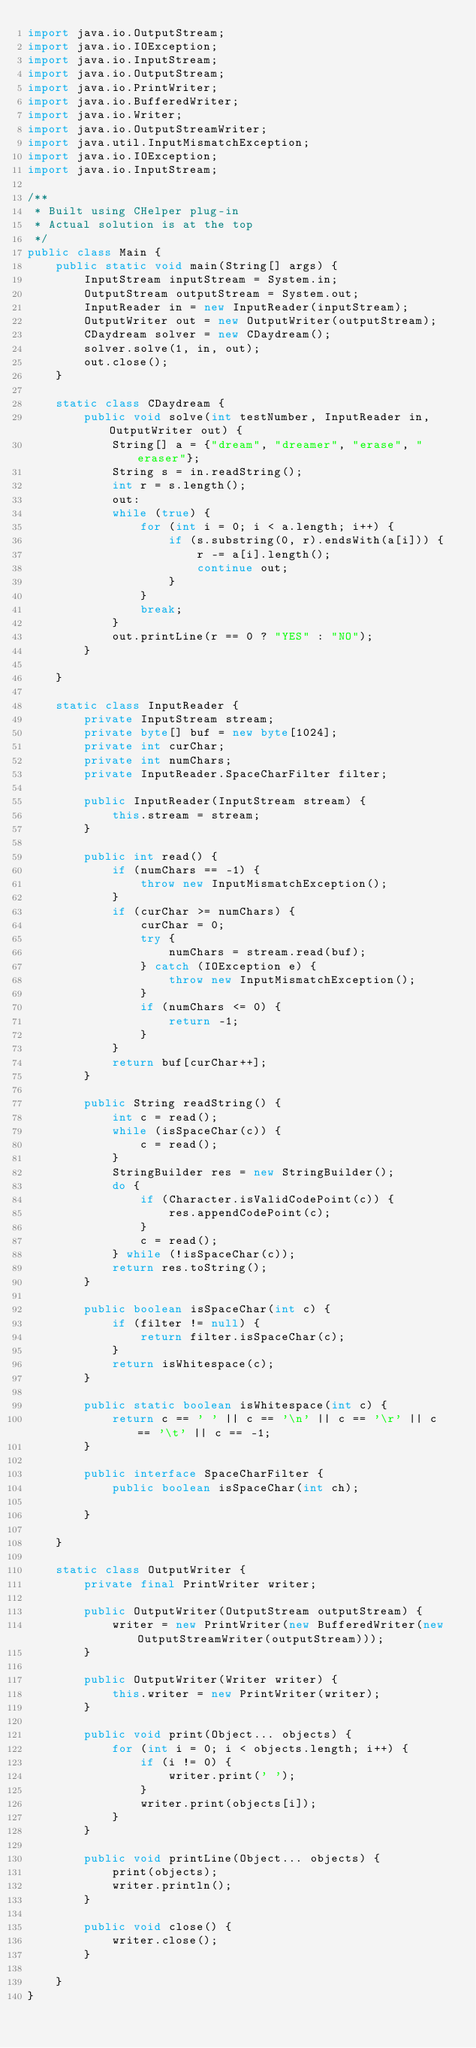<code> <loc_0><loc_0><loc_500><loc_500><_Java_>import java.io.OutputStream;
import java.io.IOException;
import java.io.InputStream;
import java.io.OutputStream;
import java.io.PrintWriter;
import java.io.BufferedWriter;
import java.io.Writer;
import java.io.OutputStreamWriter;
import java.util.InputMismatchException;
import java.io.IOException;
import java.io.InputStream;

/**
 * Built using CHelper plug-in
 * Actual solution is at the top
 */
public class Main {
    public static void main(String[] args) {
        InputStream inputStream = System.in;
        OutputStream outputStream = System.out;
        InputReader in = new InputReader(inputStream);
        OutputWriter out = new OutputWriter(outputStream);
        CDaydream solver = new CDaydream();
        solver.solve(1, in, out);
        out.close();
    }

    static class CDaydream {
        public void solve(int testNumber, InputReader in, OutputWriter out) {
            String[] a = {"dream", "dreamer", "erase", "eraser"};
            String s = in.readString();
            int r = s.length();
            out:
            while (true) {
                for (int i = 0; i < a.length; i++) {
                    if (s.substring(0, r).endsWith(a[i])) {
                        r -= a[i].length();
                        continue out;
                    }
                }
                break;
            }
            out.printLine(r == 0 ? "YES" : "NO");
        }

    }

    static class InputReader {
        private InputStream stream;
        private byte[] buf = new byte[1024];
        private int curChar;
        private int numChars;
        private InputReader.SpaceCharFilter filter;

        public InputReader(InputStream stream) {
            this.stream = stream;
        }

        public int read() {
            if (numChars == -1) {
                throw new InputMismatchException();
            }
            if (curChar >= numChars) {
                curChar = 0;
                try {
                    numChars = stream.read(buf);
                } catch (IOException e) {
                    throw new InputMismatchException();
                }
                if (numChars <= 0) {
                    return -1;
                }
            }
            return buf[curChar++];
        }

        public String readString() {
            int c = read();
            while (isSpaceChar(c)) {
                c = read();
            }
            StringBuilder res = new StringBuilder();
            do {
                if (Character.isValidCodePoint(c)) {
                    res.appendCodePoint(c);
                }
                c = read();
            } while (!isSpaceChar(c));
            return res.toString();
        }

        public boolean isSpaceChar(int c) {
            if (filter != null) {
                return filter.isSpaceChar(c);
            }
            return isWhitespace(c);
        }

        public static boolean isWhitespace(int c) {
            return c == ' ' || c == '\n' || c == '\r' || c == '\t' || c == -1;
        }

        public interface SpaceCharFilter {
            public boolean isSpaceChar(int ch);

        }

    }

    static class OutputWriter {
        private final PrintWriter writer;

        public OutputWriter(OutputStream outputStream) {
            writer = new PrintWriter(new BufferedWriter(new OutputStreamWriter(outputStream)));
        }

        public OutputWriter(Writer writer) {
            this.writer = new PrintWriter(writer);
        }

        public void print(Object... objects) {
            for (int i = 0; i < objects.length; i++) {
                if (i != 0) {
                    writer.print(' ');
                }
                writer.print(objects[i]);
            }
        }

        public void printLine(Object... objects) {
            print(objects);
            writer.println();
        }

        public void close() {
            writer.close();
        }

    }
}

</code> 